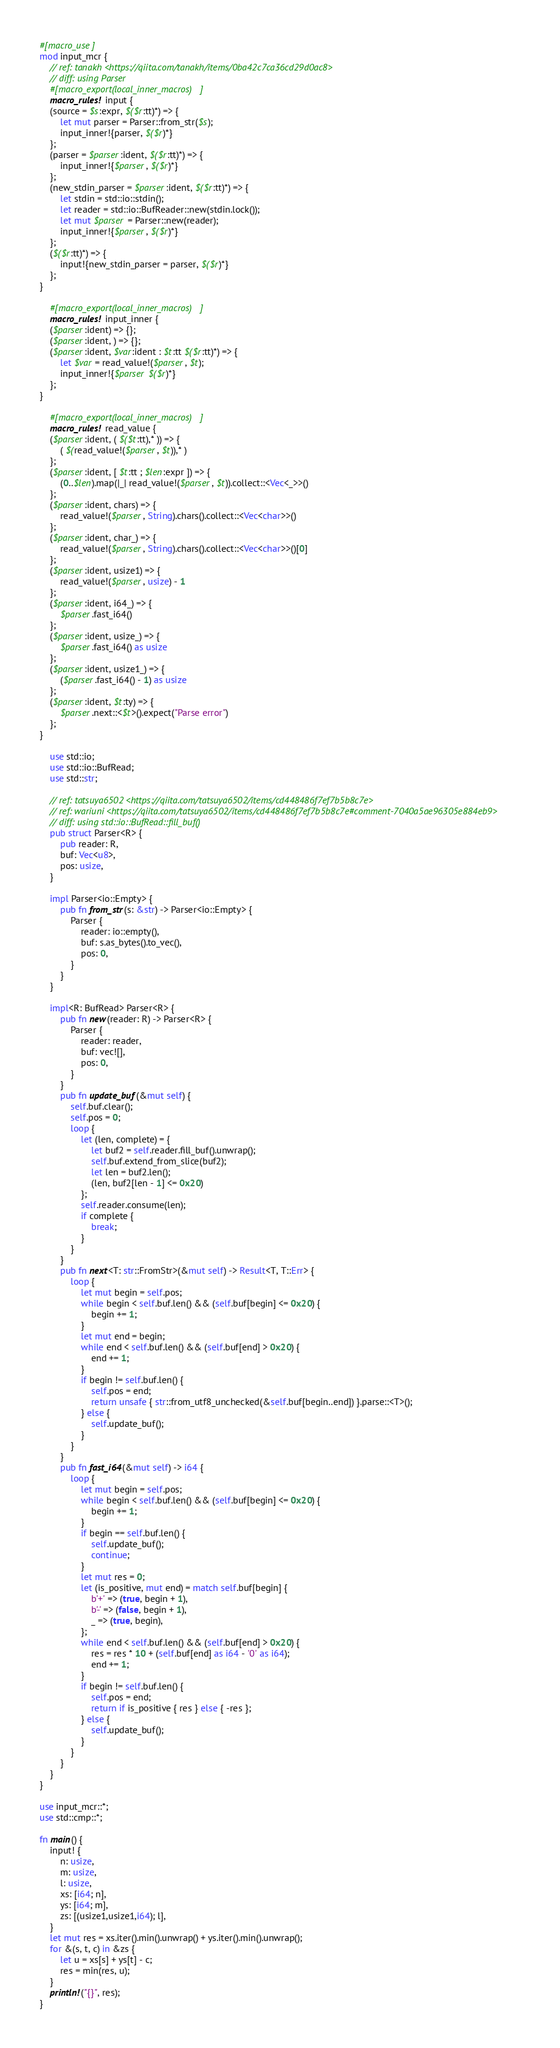<code> <loc_0><loc_0><loc_500><loc_500><_Rust_>#[macro_use]
mod input_mcr {
    // ref: tanakh <https://qiita.com/tanakh/items/0ba42c7ca36cd29d0ac8>
    // diff: using Parser
    #[macro_export(local_inner_macros)]
    macro_rules! input {
    (source = $s:expr, $($r:tt)*) => {
        let mut parser = Parser::from_str($s);
        input_inner!{parser, $($r)*}
    };
    (parser = $parser:ident, $($r:tt)*) => {
        input_inner!{$parser, $($r)*}
    };
    (new_stdin_parser = $parser:ident, $($r:tt)*) => {
        let stdin = std::io::stdin();
        let reader = std::io::BufReader::new(stdin.lock());
        let mut $parser = Parser::new(reader);
        input_inner!{$parser, $($r)*}
    };
    ($($r:tt)*) => {
        input!{new_stdin_parser = parser, $($r)*}
    };
}

    #[macro_export(local_inner_macros)]
    macro_rules! input_inner {
    ($parser:ident) => {};
    ($parser:ident, ) => {};
    ($parser:ident, $var:ident : $t:tt $($r:tt)*) => {
        let $var = read_value!($parser, $t);
        input_inner!{$parser $($r)*}
    };
}

    #[macro_export(local_inner_macros)]
    macro_rules! read_value {
    ($parser:ident, ( $($t:tt),* )) => {
        ( $(read_value!($parser, $t)),* )
    };
    ($parser:ident, [ $t:tt ; $len:expr ]) => {
        (0..$len).map(|_| read_value!($parser, $t)).collect::<Vec<_>>()
    };
    ($parser:ident, chars) => {
        read_value!($parser, String).chars().collect::<Vec<char>>()
    };
    ($parser:ident, char_) => {
        read_value!($parser, String).chars().collect::<Vec<char>>()[0]
    };
    ($parser:ident, usize1) => {
        read_value!($parser, usize) - 1
    };
    ($parser:ident, i64_) => {
        $parser.fast_i64()
    };
    ($parser:ident, usize_) => {
        $parser.fast_i64() as usize
    };
    ($parser:ident, usize1_) => {
        ($parser.fast_i64() - 1) as usize
    };
    ($parser:ident, $t:ty) => {
        $parser.next::<$t>().expect("Parse error")
    };
}

    use std::io;
    use std::io::BufRead;
    use std::str;

    // ref: tatsuya6502 <https://qiita.com/tatsuya6502/items/cd448486f7ef7b5b8c7e>
    // ref: wariuni <https://qiita.com/tatsuya6502/items/cd448486f7ef7b5b8c7e#comment-7040a5ae96305e884eb9>
    // diff: using std::io::BufRead::fill_buf()
    pub struct Parser<R> {
        pub reader: R,
        buf: Vec<u8>,
        pos: usize,
    }

    impl Parser<io::Empty> {
        pub fn from_str(s: &str) -> Parser<io::Empty> {
            Parser {
                reader: io::empty(),
                buf: s.as_bytes().to_vec(),
                pos: 0,
            }
        }
    }

    impl<R: BufRead> Parser<R> {
        pub fn new(reader: R) -> Parser<R> {
            Parser {
                reader: reader,
                buf: vec![],
                pos: 0,
            }
        }
        pub fn update_buf(&mut self) {
            self.buf.clear();
            self.pos = 0;
            loop {
                let (len, complete) = {
                    let buf2 = self.reader.fill_buf().unwrap();
                    self.buf.extend_from_slice(buf2);
                    let len = buf2.len();
                    (len, buf2[len - 1] <= 0x20)
                };
                self.reader.consume(len);
                if complete {
                    break;
                }
            }
        }
        pub fn next<T: str::FromStr>(&mut self) -> Result<T, T::Err> {
            loop {
                let mut begin = self.pos;
                while begin < self.buf.len() && (self.buf[begin] <= 0x20) {
                    begin += 1;
                }
                let mut end = begin;
                while end < self.buf.len() && (self.buf[end] > 0x20) {
                    end += 1;
                }
                if begin != self.buf.len() {
                    self.pos = end;
                    return unsafe { str::from_utf8_unchecked(&self.buf[begin..end]) }.parse::<T>();
                } else {
                    self.update_buf();
                }
            }
        }
        pub fn fast_i64(&mut self) -> i64 {
            loop {
                let mut begin = self.pos;
                while begin < self.buf.len() && (self.buf[begin] <= 0x20) {
                    begin += 1;
                }
                if begin == self.buf.len() {
                    self.update_buf();
                    continue;
                }
                let mut res = 0;
                let (is_positive, mut end) = match self.buf[begin] {
                    b'+' => (true, begin + 1),
                    b'-' => (false, begin + 1),
                    _ => (true, begin),
                };
                while end < self.buf.len() && (self.buf[end] > 0x20) {
                    res = res * 10 + (self.buf[end] as i64 - '0' as i64);
                    end += 1;
                }
                if begin != self.buf.len() {
                    self.pos = end;
                    return if is_positive { res } else { -res };
                } else {
                    self.update_buf();
                }
            }
        }
    }
}

use input_mcr::*;
use std::cmp::*;

fn main() {
    input! {
        n: usize,
        m: usize,
        l: usize,
        xs: [i64; n],
        ys: [i64; m],
        zs: [(usize1,usize1,i64); l],
    }
    let mut res = xs.iter().min().unwrap() + ys.iter().min().unwrap();
    for &(s, t, c) in &zs {
        let u = xs[s] + ys[t] - c;
        res = min(res, u);
    }
    println!("{}", res);
}

</code> 